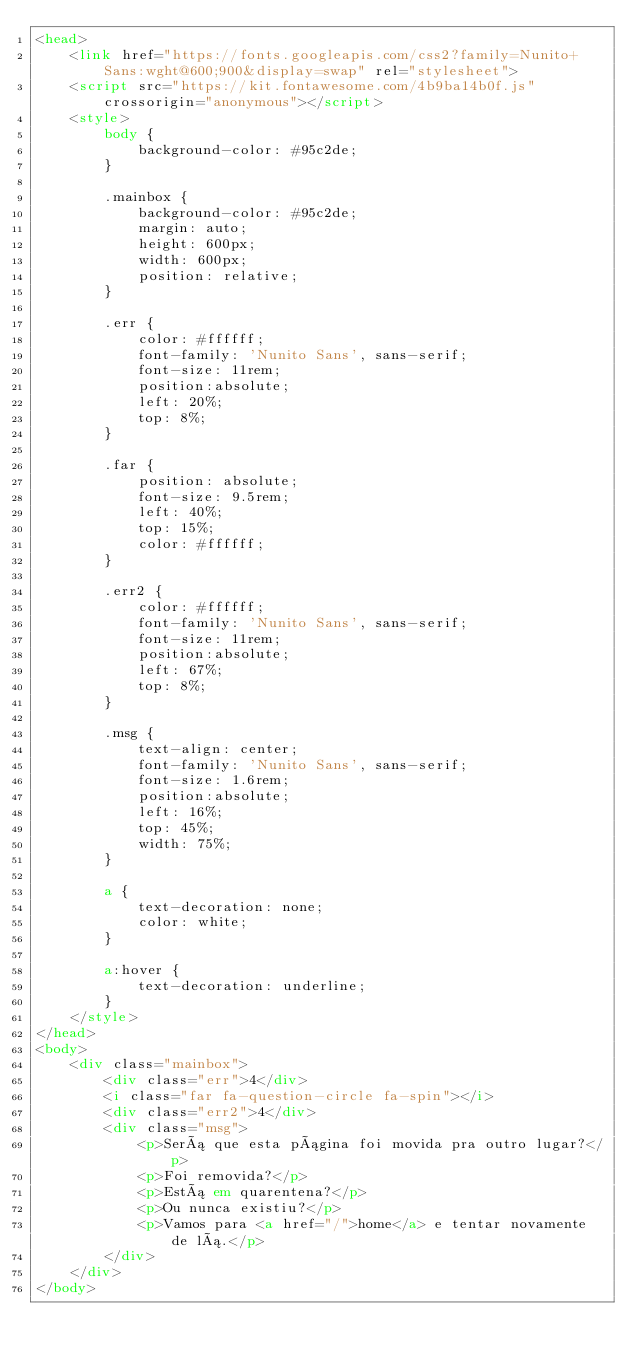<code> <loc_0><loc_0><loc_500><loc_500><_HTML_><head>
    <link href="https://fonts.googleapis.com/css2?family=Nunito+Sans:wght@600;900&display=swap" rel="stylesheet">
    <script src="https://kit.fontawesome.com/4b9ba14b0f.js" crossorigin="anonymous"></script>
    <style>
        body {
            background-color: #95c2de;
        }

        .mainbox {
            background-color: #95c2de;
            margin: auto;
            height: 600px;
            width: 600px;
            position: relative;
        }

        .err {
            color: #ffffff;
            font-family: 'Nunito Sans', sans-serif;
            font-size: 11rem;
            position:absolute;
            left: 20%;
            top: 8%;
        }

        .far {
            position: absolute;
            font-size: 9.5rem;
            left: 40%;
            top: 15%;
            color: #ffffff;
        }

        .err2 {
            color: #ffffff;
            font-family: 'Nunito Sans', sans-serif;
            font-size: 11rem;
            position:absolute;
            left: 67%;
            top: 8%;
        }

        .msg {
            text-align: center;
            font-family: 'Nunito Sans', sans-serif;
            font-size: 1.6rem;
            position:absolute;
            left: 16%;
            top: 45%;
            width: 75%;
        }

        a {
            text-decoration: none;
            color: white;
        }

        a:hover {
            text-decoration: underline;
        }
    </style>
</head>
<body>
    <div class="mainbox">
        <div class="err">4</div>
        <i class="far fa-question-circle fa-spin"></i>
        <div class="err2">4</div>
        <div class="msg">
            <p>Será que esta página foi movida pra outro lugar?</p>
            <p>Foi removida?</p>
            <p>Está em quarentena?</p> 
            <p>Ou nunca existiu?</p>
            <p>Vamos para <a href="/">home</a> e tentar novamente de lá.</p>
        </div>
    </div>
</body></code> 